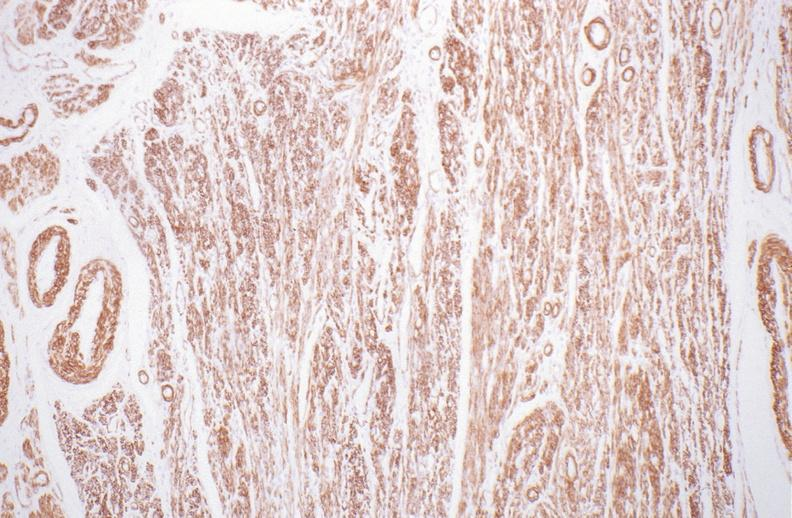what does this image show?
Answer the question using a single word or phrase. Normal uterus 